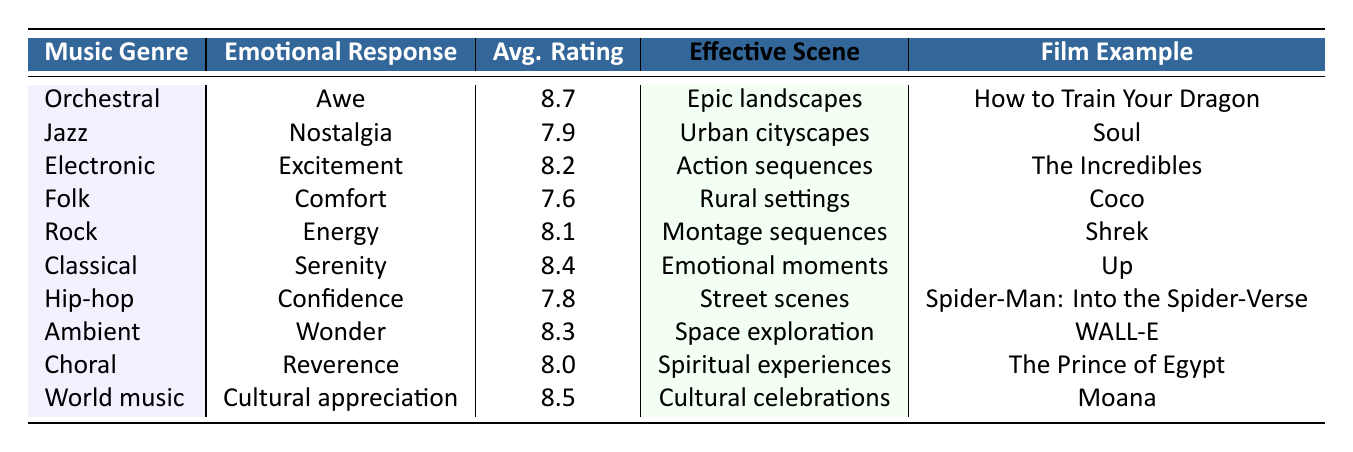What is the average audience rating for the orchestral genre? The average audience rating for the orchestral genre is listed directly in the table, which shows a rating of 8.7.
Answer: 8.7 Which emotional response is associated with electronic music? The table indicates that the emotional response associated with electronic music is excitement.
Answer: Excitement Is the most effective scene type for jazz music urban cityscapes? Referring to the table, jazz music is indeed associated with urban cityscapes as its most effective scene type.
Answer: Yes What is the average audience rating for world music? The table specifies that the average audience rating for world music is 8.5, which can be referenced directly.
Answer: 8.5 Which music genre has energy as its emotional response? The table shows that rock music has energy listed as its emotional response.
Answer: Rock What is the emotional response for hip-hop music? The emotional response for hip-hop music is confidence, as indicated in the table under the corresponding genre.
Answer: Confidence Which music genre has the highest average audience rating and what is that rating? The table lists orchestral as having the highest average audience rating of 8.7, making it the genre with the highest rating.
Answer: 8.7 How does the average audience rating for classical music compare to that for jazz music? The average rating for classical music is 8.4 and for jazz music is 7.9. Classical music has a higher average rating by 0.5.
Answer: Classical is higher by 0.5 What is the emotional response for the notable film example 'Coco'? The notable film example 'Coco' corresponds to the folk genre, which has comfort as its emotional response per the table.
Answer: Comfort Which two genres have an average audience rating below 8.0? The genres listed with average audience ratings below 8.0 are folk at 7.6 and jazz at 7.9 according to the data.
Answer: Folk and Jazz Which genre is associated with the most effective scene type of space exploration? The ambient genre is associated with the most effective scene type of space exploration as per the table.
Answer: Ambient What emotional response is produced by choral music? The table indicates that choral music produces reverence as the emotional response.
Answer: Reverence How many genres have an average audience rating of 8.0 or higher? Counting the genres with ratings of 8.0 or higher, seven genres meet this criterion based on the table data.
Answer: 7 Which film example represents world music? According to the table, the film example that represents world music is 'Moana'.
Answer: Moana 